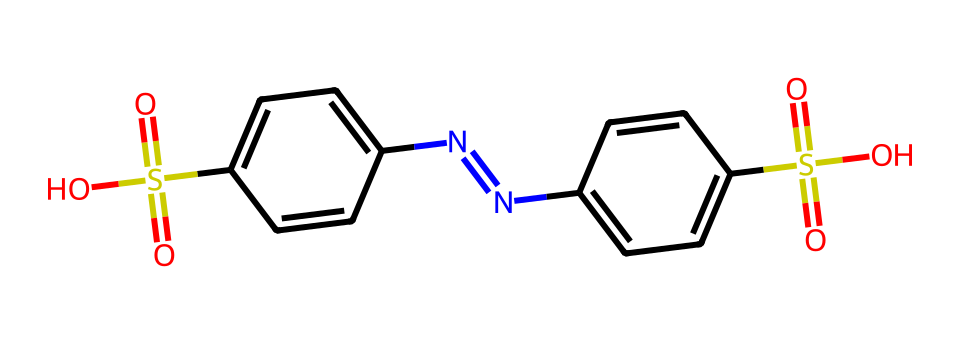What is the total number of sulfur atoms in this compound? The SMILES representation shows two instances of 'S', indicating two sulfur atoms present.
Answer: two How many nitrogen atoms are present in the molecular structure? From the SMILES string, we can identify two 'N' atoms, signifying two nitrogen atoms in the compound.
Answer: two What functional group is indicated by the "S(=O)(=O)" notation? The "S(=O)(=O)" portion of the structure represents a sulfonyl group, which consists of a sulfur atom bonded to two double-bonded oxygen atoms.
Answer: sulfonyl group What type of chemical bond connects the sulfur atoms to the surrounding atoms? The sulfur atoms are primarily bonded through covalent bonds to the oxygen and carbon atoms, as indicated by their structure in the SMILES representation.
Answer: covalent bonds What is the role of the sulfur atoms in terms of color properties in dyes? Sulfur atoms in dyes often involve specific functional groups that enhance color vibrancy and stability, making the dyes more effective for fabrics.
Answer: color vibrancy How many rings are found in the chemical structure? Analyzing the structure reveals two distinct aromatic rings based on the cyclic arrangements indicated by the SMILES notation.
Answer: two rings Which part of the molecule suggests its use as a dye? The presence of the sulfonyl groups and the overall aromatic structure suggest that it is designed for vivid coloration in textiles, a common characteristic of dyes.
Answer: sulfonyl groups 